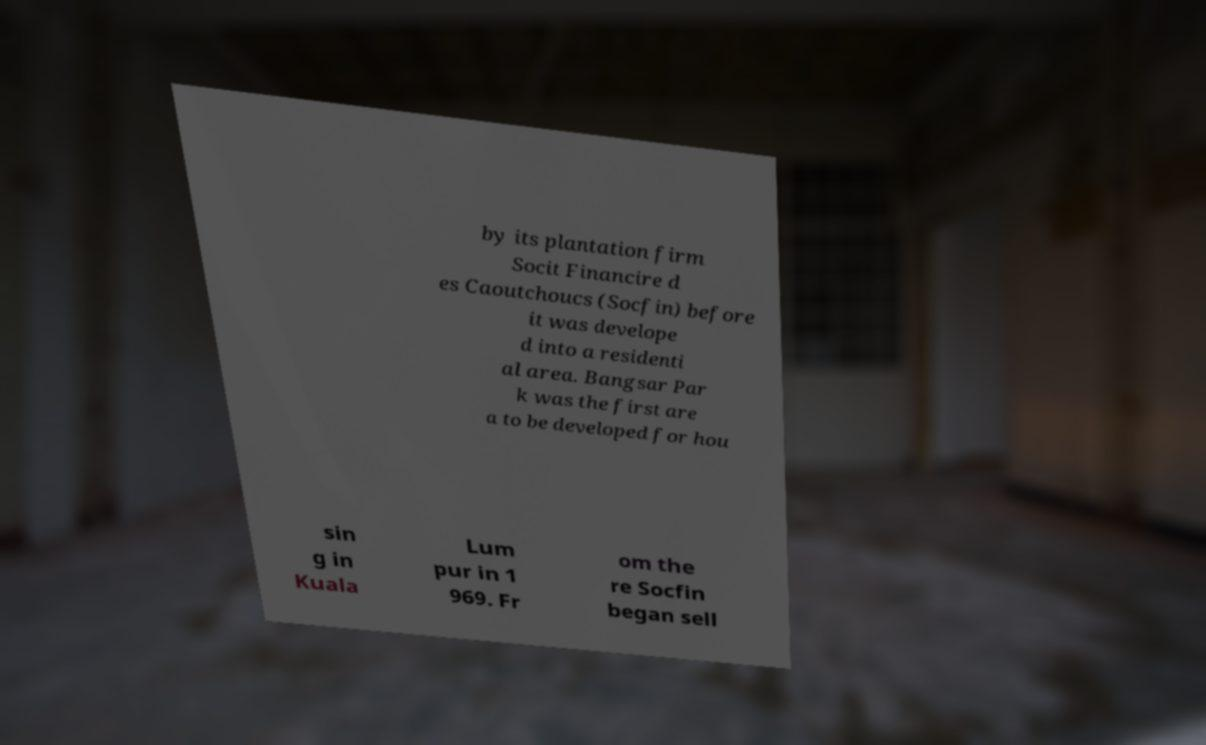What messages or text are displayed in this image? I need them in a readable, typed format. by its plantation firm Socit Financire d es Caoutchoucs (Socfin) before it was develope d into a residenti al area. Bangsar Par k was the first are a to be developed for hou sin g in Kuala Lum pur in 1 969. Fr om the re Socfin began sell 